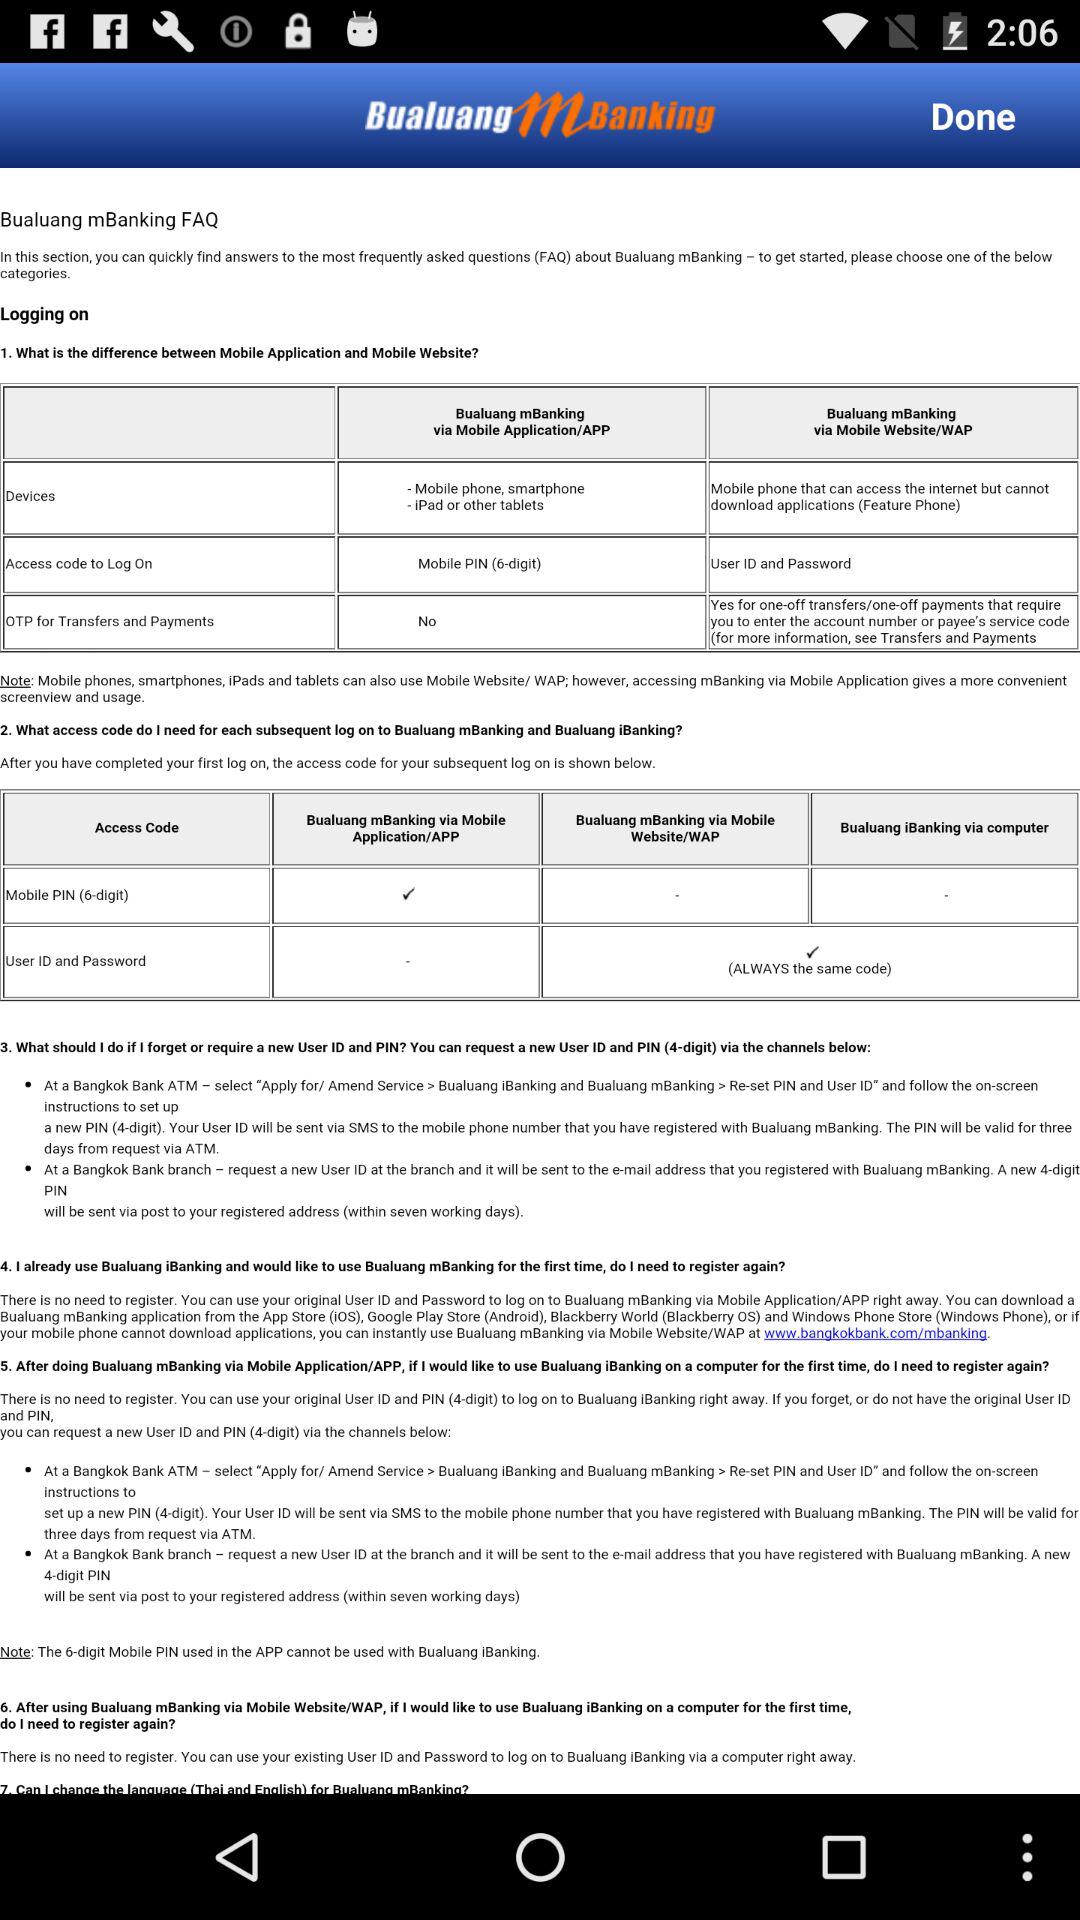What is the application name? The application name is "BualuangmBanking". 